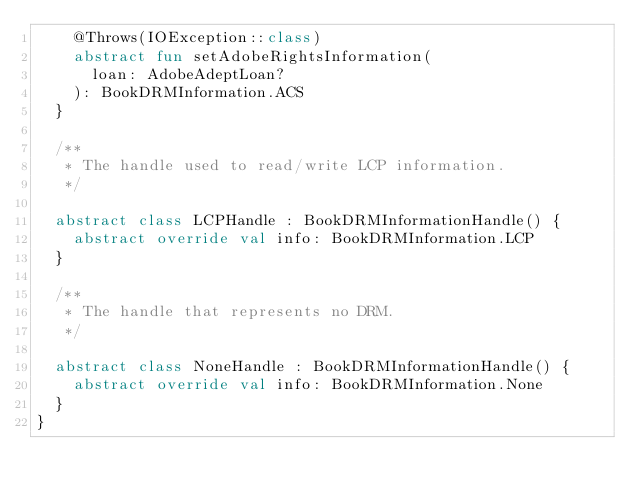Convert code to text. <code><loc_0><loc_0><loc_500><loc_500><_Kotlin_>    @Throws(IOException::class)
    abstract fun setAdobeRightsInformation(
      loan: AdobeAdeptLoan?
    ): BookDRMInformation.ACS
  }

  /**
   * The handle used to read/write LCP information.
   */

  abstract class LCPHandle : BookDRMInformationHandle() {
    abstract override val info: BookDRMInformation.LCP
  }

  /**
   * The handle that represents no DRM.
   */

  abstract class NoneHandle : BookDRMInformationHandle() {
    abstract override val info: BookDRMInformation.None
  }
}
</code> 